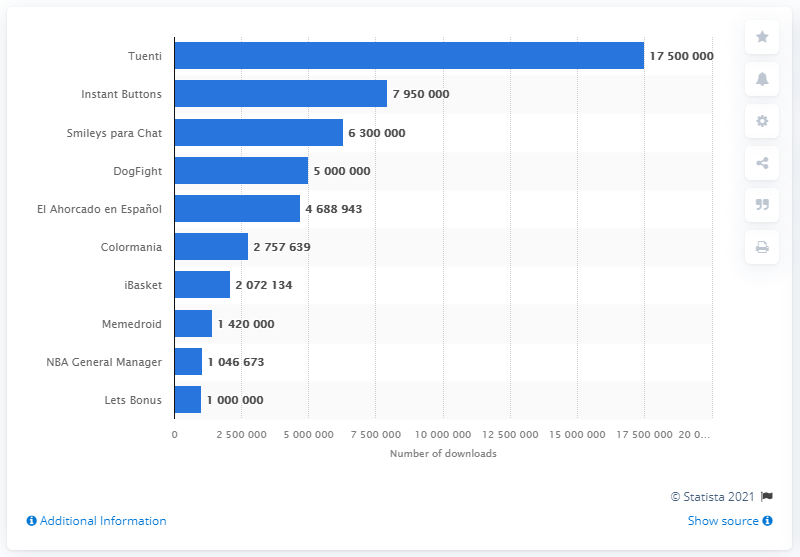Specify some key components in this picture. In 2014, Tuenti was the most downloaded app in Spain. 